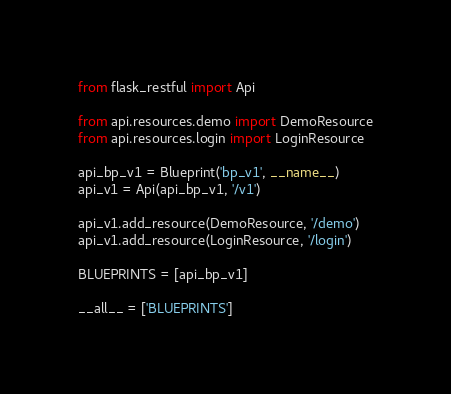<code> <loc_0><loc_0><loc_500><loc_500><_Python_>from flask_restful import Api

from api.resources.demo import DemoResource
from api.resources.login import LoginResource

api_bp_v1 = Blueprint('bp_v1', __name__)
api_v1 = Api(api_bp_v1, '/v1')

api_v1.add_resource(DemoResource, '/demo')
api_v1.add_resource(LoginResource, '/login')

BLUEPRINTS = [api_bp_v1]

__all__ = ['BLUEPRINTS']
</code> 